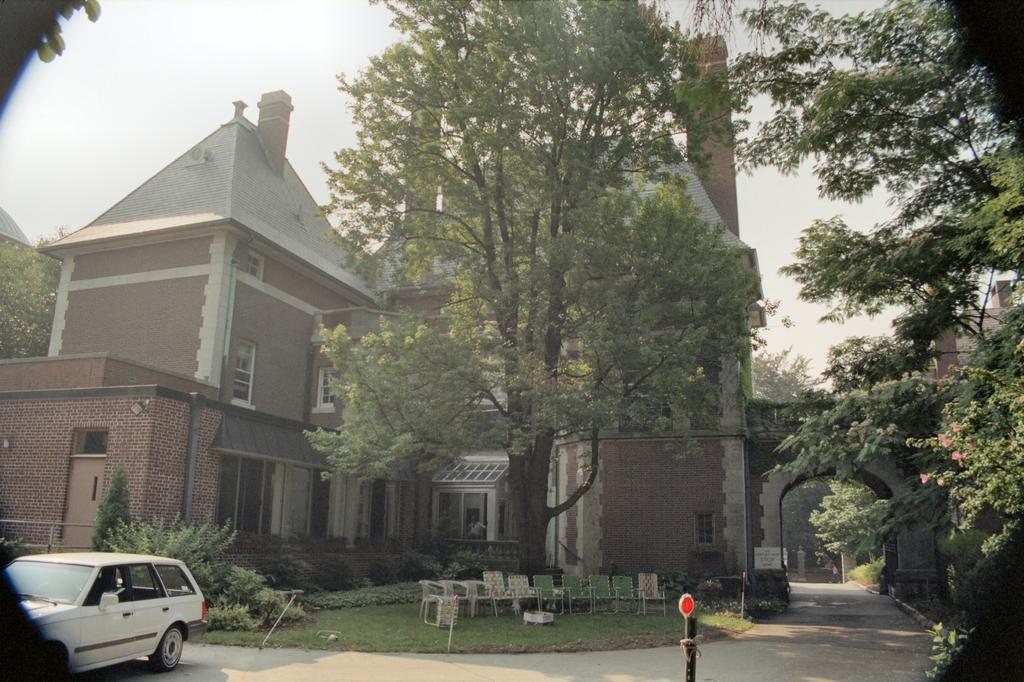In one or two sentences, can you explain what this image depicts? On the left side of the image we can see a car on the road. On the right there is an arch. In the center there are buildings and trees. At the bottom there are chairs and bushes. In the background there is sky. 